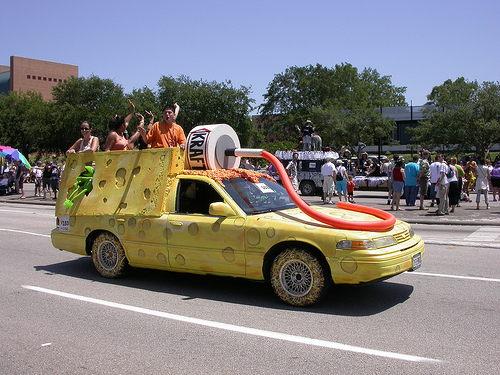<image>
Is the frog next to the tire? No. The frog is not positioned next to the tire. They are located in different areas of the scene. 